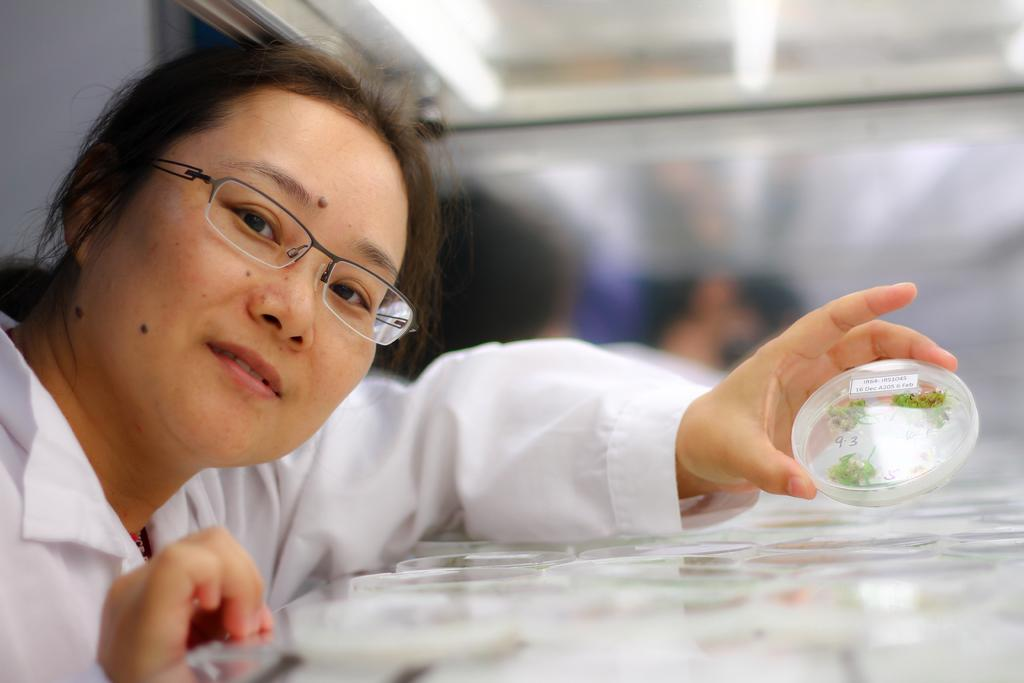Who is the main subject in the image? There is a woman in the image. What is the woman wearing? The woman is wearing a white dress. What is the woman holding in the image? The woman is holding a small box. What is inside the small box? The small box contains small leaves. Can you describe the background of the image? The background of the image is blurred. What type of amusement park can be seen in the background of the image? There is no amusement park present in the image; the background is blurred. 